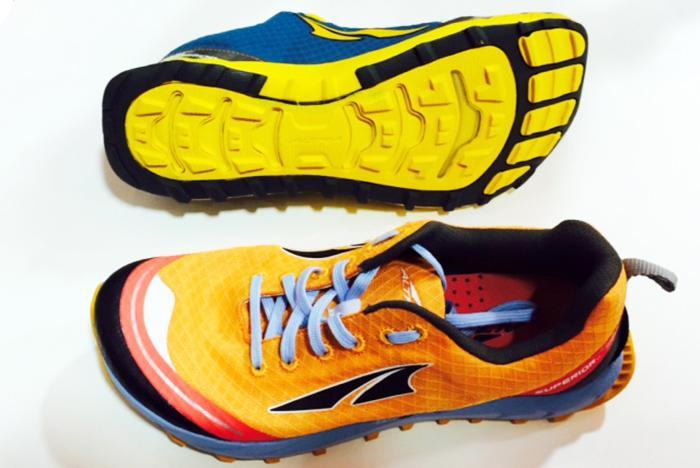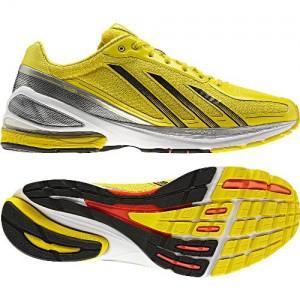The first image is the image on the left, the second image is the image on the right. Given the left and right images, does the statement "In at least one photo there is a teal shoe with gray trimming and yellow laces facing right." hold true? Answer yes or no. No. 